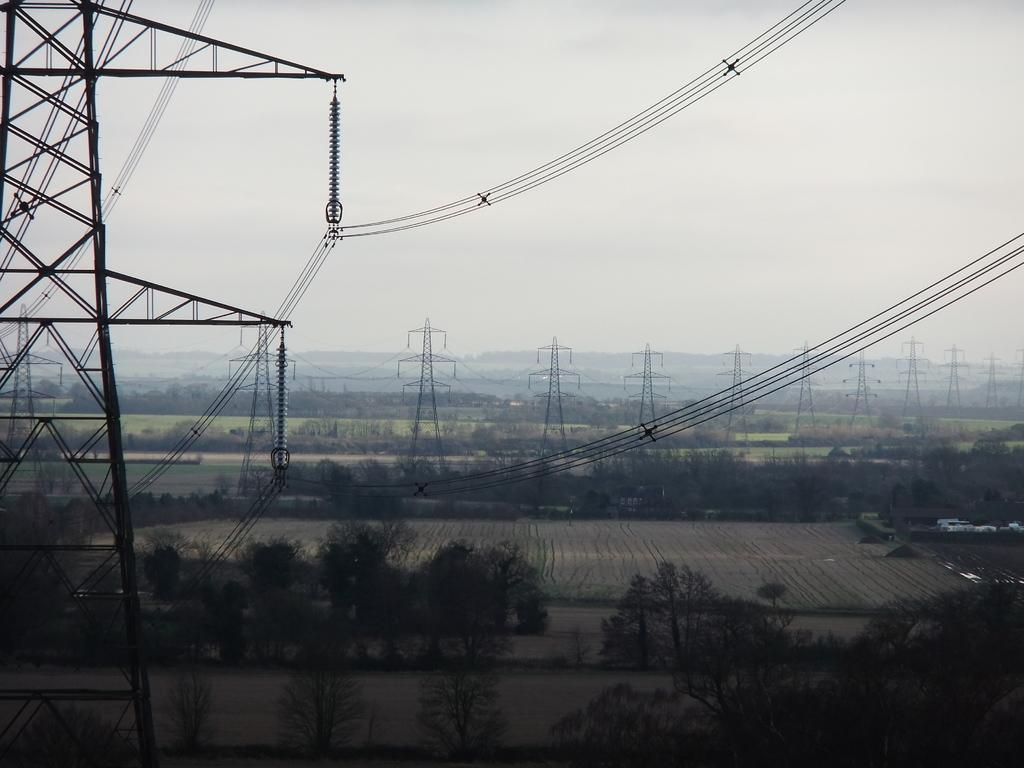What type of vegetation can be seen in the image? There is a group of trees in the image. What can be seen in the background of the image? There are fields visible in the image. Where are the towers with wires located in the image? A tower and wires are present on the left side of the image. What is visible at the top of the image? The sky is visible at the top of the image. What type of orange is being used for acoustics in the image? There is no orange present in the image, and the concept of using an orange for acoustics is not relevant to the image. 